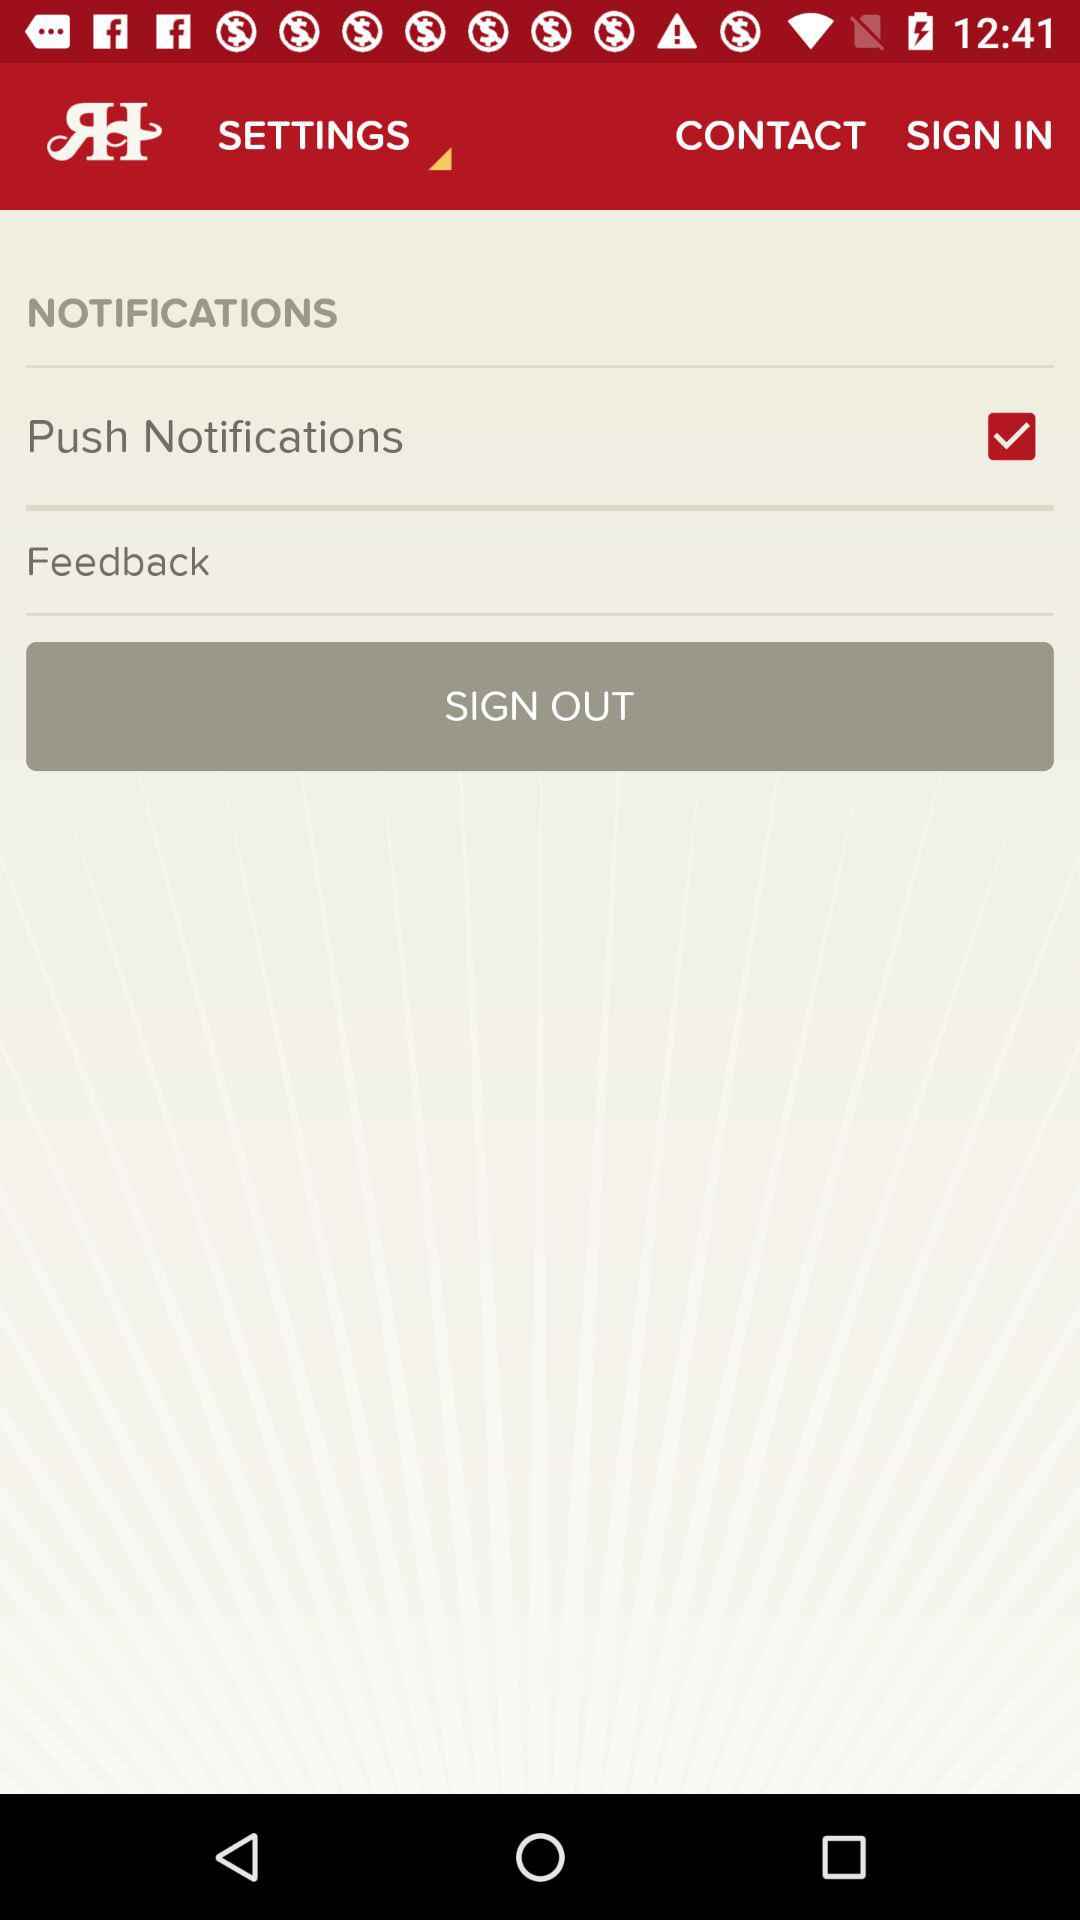Which options are marked as checked? The option is "Push Notifications". 